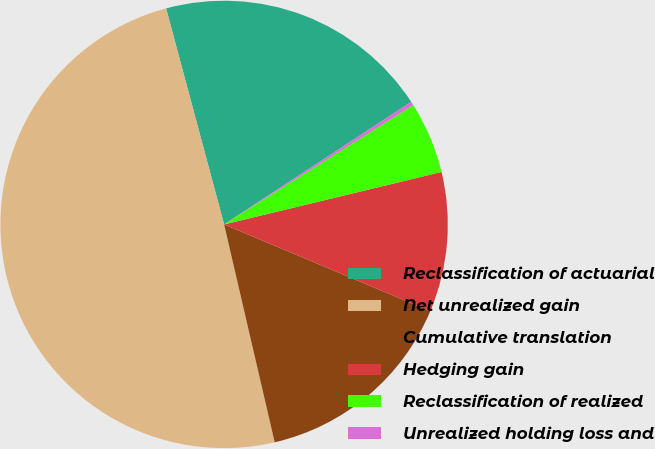<chart> <loc_0><loc_0><loc_500><loc_500><pie_chart><fcel>Reclassification of actuarial<fcel>Net unrealized gain<fcel>Cumulative translation<fcel>Hedging gain<fcel>Reclassification of realized<fcel>Unrealized holding loss and<nl><fcel>19.95%<fcel>49.46%<fcel>15.03%<fcel>10.11%<fcel>5.19%<fcel>0.27%<nl></chart> 